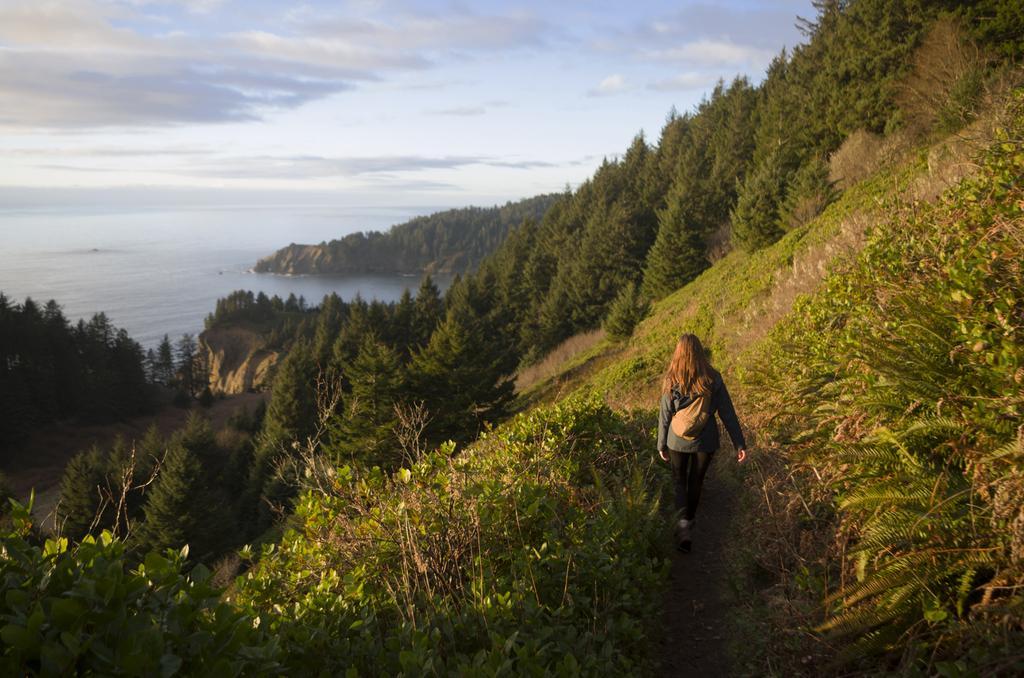How would you summarize this image in a sentence or two? In the picture I can see a woman is walking on the ground. In the background I can see trees, plants, the grass, the water and the sky. 